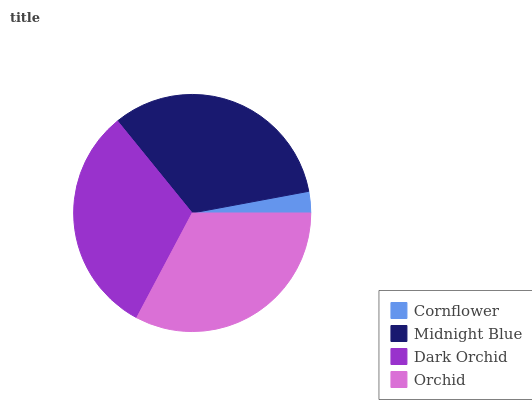Is Cornflower the minimum?
Answer yes or no. Yes. Is Midnight Blue the maximum?
Answer yes or no. Yes. Is Dark Orchid the minimum?
Answer yes or no. No. Is Dark Orchid the maximum?
Answer yes or no. No. Is Midnight Blue greater than Dark Orchid?
Answer yes or no. Yes. Is Dark Orchid less than Midnight Blue?
Answer yes or no. Yes. Is Dark Orchid greater than Midnight Blue?
Answer yes or no. No. Is Midnight Blue less than Dark Orchid?
Answer yes or no. No. Is Orchid the high median?
Answer yes or no. Yes. Is Dark Orchid the low median?
Answer yes or no. Yes. Is Midnight Blue the high median?
Answer yes or no. No. Is Midnight Blue the low median?
Answer yes or no. No. 